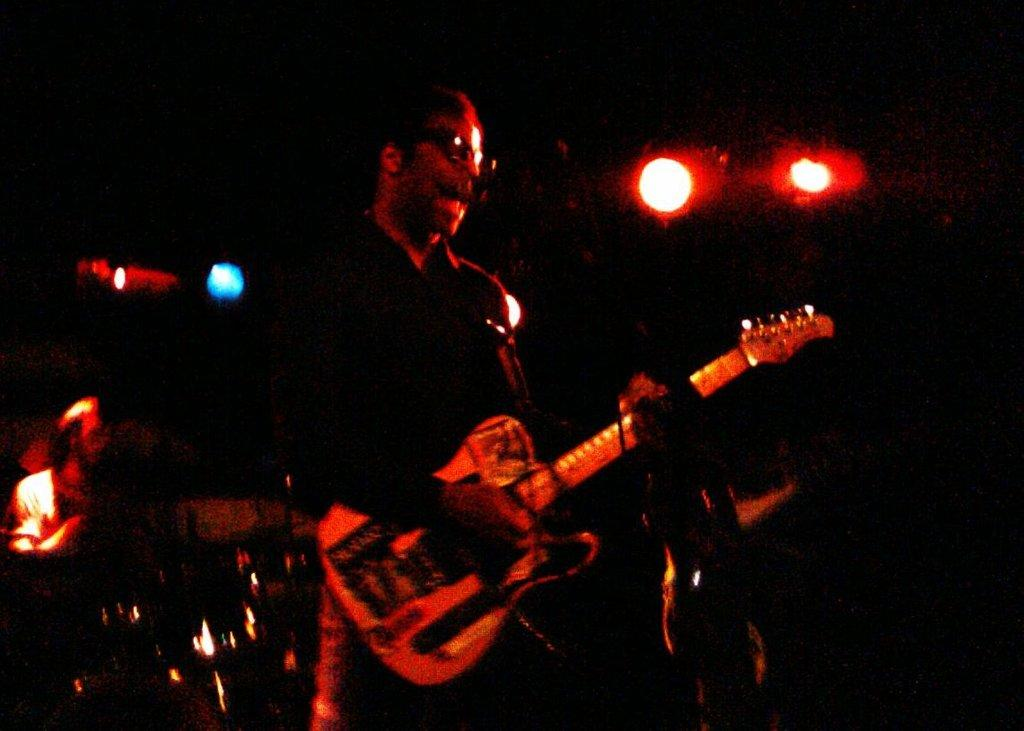What is the main subject of the image? There is a person standing in the center of the image. What is the person holding? The person is holding a guitar. Are there any other people in the image? Yes, there is a person sitting on the backside. What else can be seen in the image besides the people? Musical instruments and lights are visible in the image. What type of grass is growing on the person's neck in the image? There is no grass growing on the person's neck in the image. What is the chance of the person playing the guitar winning a talent show in the image? The image does not provide any information about a talent show or the person's chances of winning, so we cannot answer this question. 